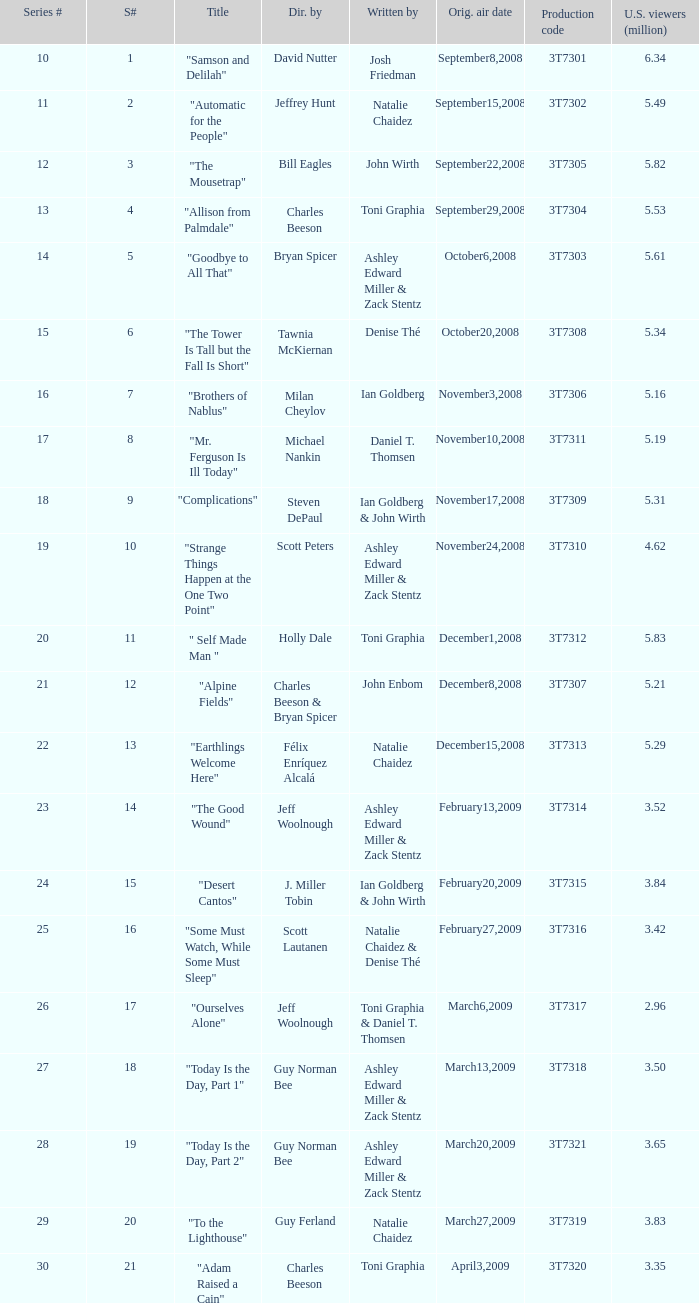Which episode number drew in 3.84 million viewers in the U.S.? 24.0. 